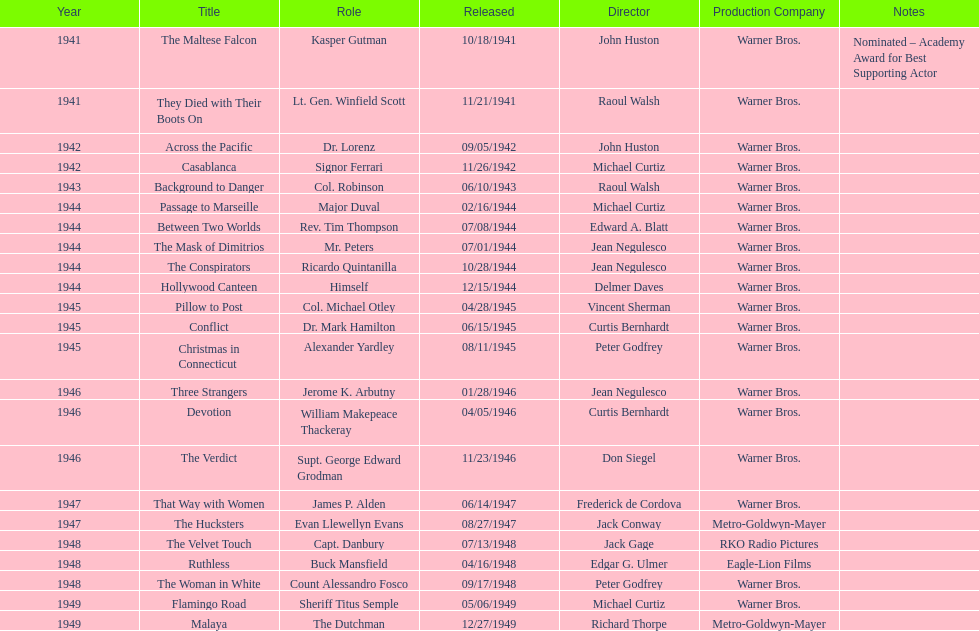What motion pictures did greenstreet perform in for 1946? Three Strangers, Devotion, The Verdict. 